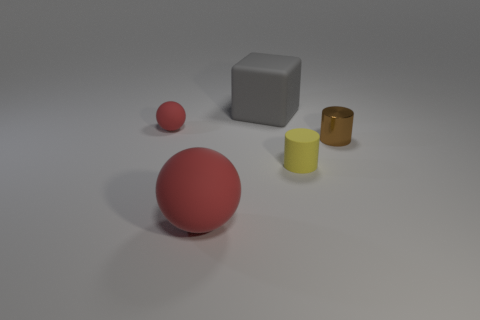How many small rubber things are on the right side of the large gray cube to the right of the tiny sphere?
Your answer should be compact. 1. There is a red matte thing that is behind the small matte object right of the small rubber object that is on the left side of the gray object; what size is it?
Your answer should be compact. Small. The matte ball on the left side of the large thing in front of the yellow rubber cylinder is what color?
Provide a short and direct response. Red. How many other things are there of the same material as the big block?
Give a very brief answer. 3. How many other things are the same color as the block?
Provide a short and direct response. 0. The small cylinder on the left side of the thing to the right of the yellow object is made of what material?
Offer a very short reply. Rubber. Are any tiny gray rubber cylinders visible?
Offer a very short reply. No. There is a matte thing that is right of the large object behind the big red rubber object; what is its size?
Offer a terse response. Small. Are there more brown objects that are to the left of the tiny red object than tiny red spheres to the right of the shiny thing?
Your response must be concise. No. What number of cylinders are either shiny things or small matte objects?
Provide a succinct answer. 2. 